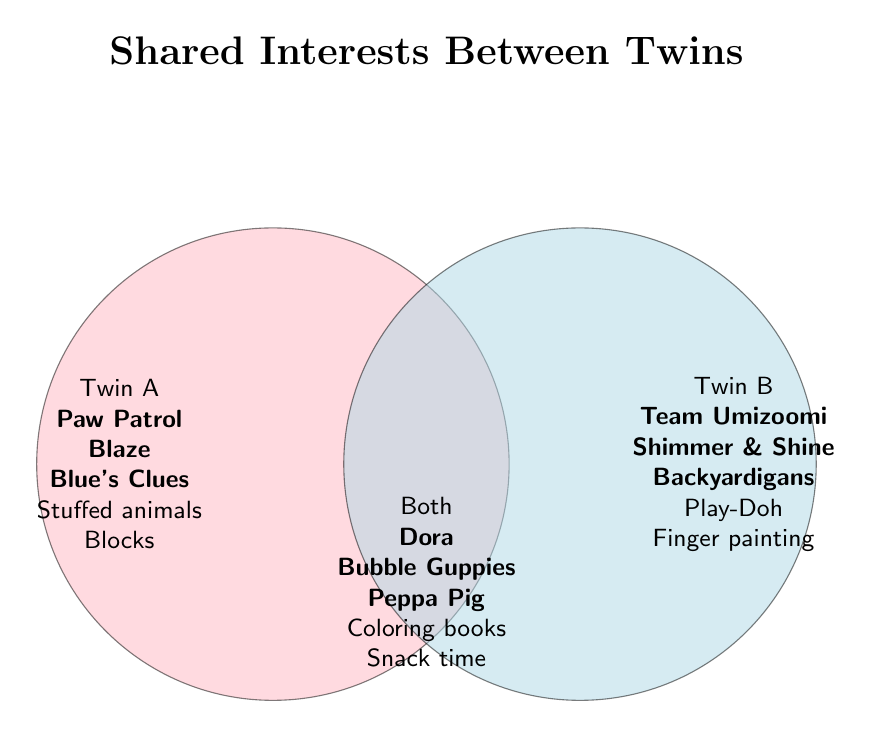What is the title of the Venn Diagram? The title is displayed at the top of the diagram. It reads "Shared Interests Between Twins."
Answer: Shared Interests Between Twins Which shows do both twins like? The shows that both twins like are listed in the overlapping section of the diagram under "Both." They are Dora the Explorer, Bubble Guppies, and Peppa Pig.
Answer: Dora the Explorer, Bubble Guppies, Peppa Pig Which activities are unique to Twin B? The activities listed under Twin B include Play-Doh and Finger painting. These activities do not appear in the overlap or under Twin A.
Answer: Play-Doh, Finger painting How many unique activities does Twin A have? To find the number of unique activities for Twin A, count the items listed in the Twin A section. There are three: Stuffed animals, Building blocks, and Blaze and the Monster Machines.
Answer: 3 List all activities that both twins share. The shared activities are listed in the overlapping section of the diagram under "Both." They are Coloring books and Snack time.
Answer: Coloring books, Snack time Which twin likes Blue's Clues? Blue's Clues is listed under the section for Twin A.
Answer: Twin A Does Twin B like Team Umizoomi? Yes, Team Umizoomi is listed under Twin B.
Answer: Yes Which twin has more unique preferences? To determine which twin has more unique preferences, count the items under Twin A and Twin B separately. Twin A has three unique items (Stuffed animals, Building blocks, Blaze and the Monster Machines), while Twin B has three unique items (Play-Doh, Finger painting, Team Umizoomi). The counts are equal.
Answer: Equal Are there more shared interests or unique interests for each twin? Count the items in each section. Both twins share 5 items (3 shows + 2 activities). Twin A has three unique items and Twin B has three unique items. The shared interests (5) are greater than the unique interests for each twin individually (3 each).
Answer: More shared interests Who enjoys Peppa Pig? Peppa Pig is listed in the shared section, meaning both twins enjoy it.
Answer: Both twins 